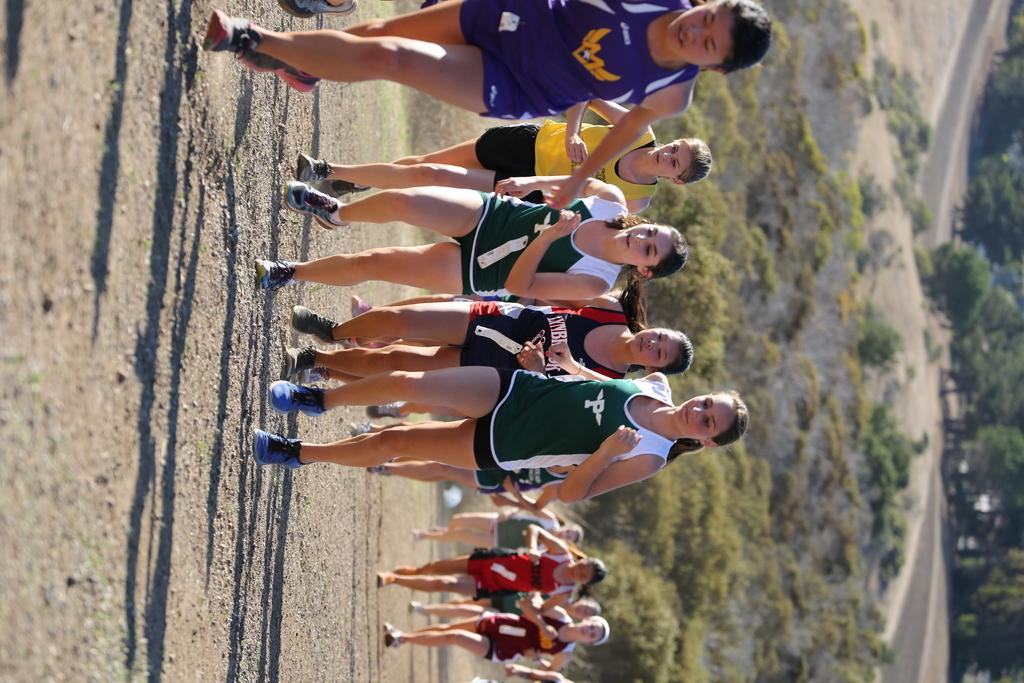What are the people in the image doing? The people in the image are running. What are the people wearing while running? The people are wearing jerseys and shoes. What can be seen in the background of the image? There is a mountain in the background of the image. What is the appearance of the mountain? The mountain is covered with trees. What is the answer to the riddle on the back of the jerseys in the image? There is no riddle present on the back of the jerseys in the image. Can you see a kitty playing with a ball in the image? There is no kitty or ball present in the image. 